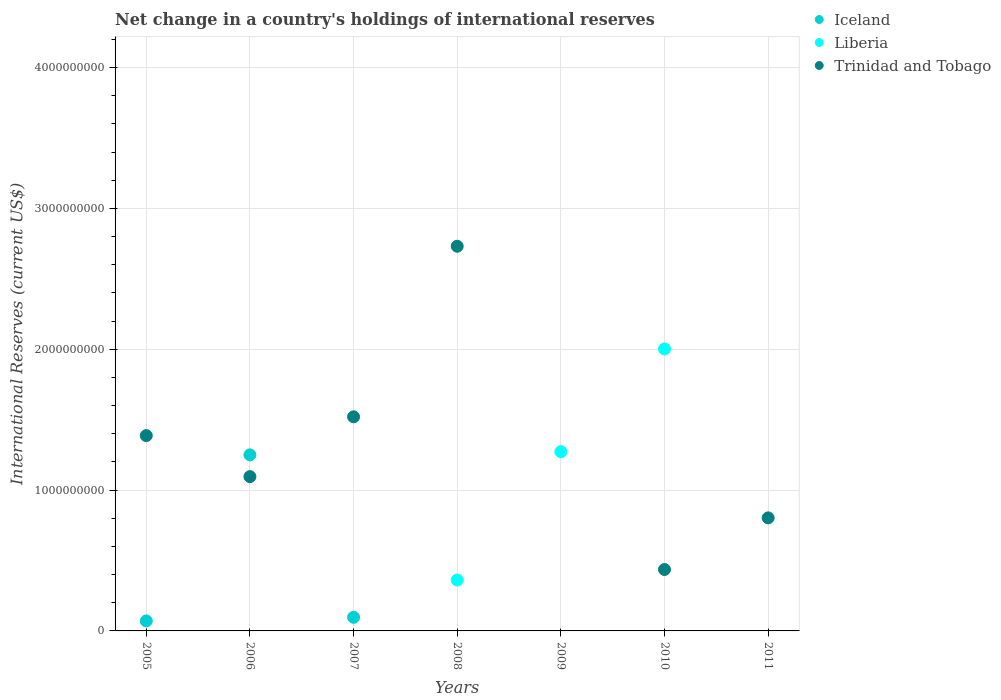How many different coloured dotlines are there?
Keep it short and to the point. 3. Is the number of dotlines equal to the number of legend labels?
Offer a terse response. No. What is the international reserves in Trinidad and Tobago in 2011?
Provide a succinct answer. 8.03e+08. Across all years, what is the maximum international reserves in Liberia?
Provide a short and direct response. 2.00e+09. Across all years, what is the minimum international reserves in Trinidad and Tobago?
Your answer should be very brief. 0. In which year was the international reserves in Iceland maximum?
Your response must be concise. 2006. What is the total international reserves in Trinidad and Tobago in the graph?
Keep it short and to the point. 7.97e+09. What is the difference between the international reserves in Iceland in 2006 and that in 2007?
Provide a succinct answer. 1.15e+09. What is the difference between the international reserves in Iceland in 2011 and the international reserves in Liberia in 2005?
Give a very brief answer. 0. What is the average international reserves in Liberia per year?
Keep it short and to the point. 5.20e+08. In the year 2008, what is the difference between the international reserves in Trinidad and Tobago and international reserves in Liberia?
Your response must be concise. 2.37e+09. What is the ratio of the international reserves in Liberia in 2009 to that in 2010?
Offer a terse response. 0.64. What is the difference between the highest and the second highest international reserves in Liberia?
Provide a short and direct response. 7.30e+08. What is the difference between the highest and the lowest international reserves in Trinidad and Tobago?
Provide a short and direct response. 2.73e+09. Is the sum of the international reserves in Trinidad and Tobago in 2008 and 2010 greater than the maximum international reserves in Iceland across all years?
Provide a short and direct response. Yes. Is the international reserves in Iceland strictly greater than the international reserves in Trinidad and Tobago over the years?
Offer a terse response. No. How many dotlines are there?
Offer a very short reply. 3. What is the difference between two consecutive major ticks on the Y-axis?
Give a very brief answer. 1.00e+09. Are the values on the major ticks of Y-axis written in scientific E-notation?
Keep it short and to the point. No. Does the graph contain any zero values?
Give a very brief answer. Yes. What is the title of the graph?
Provide a succinct answer. Net change in a country's holdings of international reserves. Does "Australia" appear as one of the legend labels in the graph?
Offer a terse response. No. What is the label or title of the X-axis?
Offer a very short reply. Years. What is the label or title of the Y-axis?
Your answer should be very brief. International Reserves (current US$). What is the International Reserves (current US$) of Iceland in 2005?
Provide a succinct answer. 7.10e+07. What is the International Reserves (current US$) in Trinidad and Tobago in 2005?
Your answer should be compact. 1.39e+09. What is the International Reserves (current US$) in Iceland in 2006?
Your answer should be compact. 1.25e+09. What is the International Reserves (current US$) of Liberia in 2006?
Your response must be concise. 0. What is the International Reserves (current US$) of Trinidad and Tobago in 2006?
Offer a very short reply. 1.10e+09. What is the International Reserves (current US$) in Iceland in 2007?
Ensure brevity in your answer.  9.67e+07. What is the International Reserves (current US$) in Trinidad and Tobago in 2007?
Keep it short and to the point. 1.52e+09. What is the International Reserves (current US$) in Liberia in 2008?
Your answer should be compact. 3.61e+08. What is the International Reserves (current US$) of Trinidad and Tobago in 2008?
Provide a succinct answer. 2.73e+09. What is the International Reserves (current US$) in Liberia in 2009?
Give a very brief answer. 1.27e+09. What is the International Reserves (current US$) in Trinidad and Tobago in 2009?
Offer a very short reply. 0. What is the International Reserves (current US$) of Liberia in 2010?
Provide a succinct answer. 2.00e+09. What is the International Reserves (current US$) in Trinidad and Tobago in 2010?
Your answer should be compact. 4.36e+08. What is the International Reserves (current US$) of Iceland in 2011?
Provide a succinct answer. 0. What is the International Reserves (current US$) of Liberia in 2011?
Provide a succinct answer. 0. What is the International Reserves (current US$) in Trinidad and Tobago in 2011?
Offer a very short reply. 8.03e+08. Across all years, what is the maximum International Reserves (current US$) in Iceland?
Your response must be concise. 1.25e+09. Across all years, what is the maximum International Reserves (current US$) in Liberia?
Make the answer very short. 2.00e+09. Across all years, what is the maximum International Reserves (current US$) in Trinidad and Tobago?
Offer a terse response. 2.73e+09. Across all years, what is the minimum International Reserves (current US$) in Trinidad and Tobago?
Give a very brief answer. 0. What is the total International Reserves (current US$) in Iceland in the graph?
Offer a terse response. 1.42e+09. What is the total International Reserves (current US$) of Liberia in the graph?
Give a very brief answer. 3.64e+09. What is the total International Reserves (current US$) of Trinidad and Tobago in the graph?
Provide a succinct answer. 7.97e+09. What is the difference between the International Reserves (current US$) of Iceland in 2005 and that in 2006?
Your answer should be very brief. -1.18e+09. What is the difference between the International Reserves (current US$) in Trinidad and Tobago in 2005 and that in 2006?
Provide a succinct answer. 2.91e+08. What is the difference between the International Reserves (current US$) in Iceland in 2005 and that in 2007?
Your response must be concise. -2.57e+07. What is the difference between the International Reserves (current US$) of Trinidad and Tobago in 2005 and that in 2007?
Make the answer very short. -1.33e+08. What is the difference between the International Reserves (current US$) of Trinidad and Tobago in 2005 and that in 2008?
Make the answer very short. -1.34e+09. What is the difference between the International Reserves (current US$) of Trinidad and Tobago in 2005 and that in 2010?
Your answer should be compact. 9.51e+08. What is the difference between the International Reserves (current US$) of Trinidad and Tobago in 2005 and that in 2011?
Your response must be concise. 5.84e+08. What is the difference between the International Reserves (current US$) of Iceland in 2006 and that in 2007?
Keep it short and to the point. 1.15e+09. What is the difference between the International Reserves (current US$) of Trinidad and Tobago in 2006 and that in 2007?
Keep it short and to the point. -4.25e+08. What is the difference between the International Reserves (current US$) in Trinidad and Tobago in 2006 and that in 2008?
Provide a succinct answer. -1.64e+09. What is the difference between the International Reserves (current US$) of Trinidad and Tobago in 2006 and that in 2010?
Your answer should be compact. 6.60e+08. What is the difference between the International Reserves (current US$) in Trinidad and Tobago in 2006 and that in 2011?
Make the answer very short. 2.93e+08. What is the difference between the International Reserves (current US$) in Trinidad and Tobago in 2007 and that in 2008?
Ensure brevity in your answer.  -1.21e+09. What is the difference between the International Reserves (current US$) in Trinidad and Tobago in 2007 and that in 2010?
Your answer should be compact. 1.08e+09. What is the difference between the International Reserves (current US$) of Trinidad and Tobago in 2007 and that in 2011?
Make the answer very short. 7.18e+08. What is the difference between the International Reserves (current US$) of Liberia in 2008 and that in 2009?
Offer a very short reply. -9.12e+08. What is the difference between the International Reserves (current US$) in Liberia in 2008 and that in 2010?
Ensure brevity in your answer.  -1.64e+09. What is the difference between the International Reserves (current US$) in Trinidad and Tobago in 2008 and that in 2010?
Provide a succinct answer. 2.30e+09. What is the difference between the International Reserves (current US$) of Trinidad and Tobago in 2008 and that in 2011?
Give a very brief answer. 1.93e+09. What is the difference between the International Reserves (current US$) of Liberia in 2009 and that in 2010?
Keep it short and to the point. -7.30e+08. What is the difference between the International Reserves (current US$) in Trinidad and Tobago in 2010 and that in 2011?
Your response must be concise. -3.67e+08. What is the difference between the International Reserves (current US$) of Iceland in 2005 and the International Reserves (current US$) of Trinidad and Tobago in 2006?
Your response must be concise. -1.02e+09. What is the difference between the International Reserves (current US$) of Iceland in 2005 and the International Reserves (current US$) of Trinidad and Tobago in 2007?
Give a very brief answer. -1.45e+09. What is the difference between the International Reserves (current US$) in Iceland in 2005 and the International Reserves (current US$) in Liberia in 2008?
Your answer should be very brief. -2.90e+08. What is the difference between the International Reserves (current US$) of Iceland in 2005 and the International Reserves (current US$) of Trinidad and Tobago in 2008?
Provide a succinct answer. -2.66e+09. What is the difference between the International Reserves (current US$) in Iceland in 2005 and the International Reserves (current US$) in Liberia in 2009?
Your answer should be compact. -1.20e+09. What is the difference between the International Reserves (current US$) in Iceland in 2005 and the International Reserves (current US$) in Liberia in 2010?
Keep it short and to the point. -1.93e+09. What is the difference between the International Reserves (current US$) in Iceland in 2005 and the International Reserves (current US$) in Trinidad and Tobago in 2010?
Give a very brief answer. -3.65e+08. What is the difference between the International Reserves (current US$) in Iceland in 2005 and the International Reserves (current US$) in Trinidad and Tobago in 2011?
Your response must be concise. -7.32e+08. What is the difference between the International Reserves (current US$) in Iceland in 2006 and the International Reserves (current US$) in Trinidad and Tobago in 2007?
Your answer should be very brief. -2.70e+08. What is the difference between the International Reserves (current US$) of Iceland in 2006 and the International Reserves (current US$) of Liberia in 2008?
Provide a short and direct response. 8.89e+08. What is the difference between the International Reserves (current US$) in Iceland in 2006 and the International Reserves (current US$) in Trinidad and Tobago in 2008?
Provide a succinct answer. -1.48e+09. What is the difference between the International Reserves (current US$) in Iceland in 2006 and the International Reserves (current US$) in Liberia in 2009?
Your answer should be compact. -2.28e+07. What is the difference between the International Reserves (current US$) in Iceland in 2006 and the International Reserves (current US$) in Liberia in 2010?
Provide a short and direct response. -7.52e+08. What is the difference between the International Reserves (current US$) in Iceland in 2006 and the International Reserves (current US$) in Trinidad and Tobago in 2010?
Offer a very short reply. 8.14e+08. What is the difference between the International Reserves (current US$) of Iceland in 2006 and the International Reserves (current US$) of Trinidad and Tobago in 2011?
Make the answer very short. 4.47e+08. What is the difference between the International Reserves (current US$) of Iceland in 2007 and the International Reserves (current US$) of Liberia in 2008?
Your answer should be very brief. -2.65e+08. What is the difference between the International Reserves (current US$) of Iceland in 2007 and the International Reserves (current US$) of Trinidad and Tobago in 2008?
Give a very brief answer. -2.63e+09. What is the difference between the International Reserves (current US$) of Iceland in 2007 and the International Reserves (current US$) of Liberia in 2009?
Your answer should be very brief. -1.18e+09. What is the difference between the International Reserves (current US$) in Iceland in 2007 and the International Reserves (current US$) in Liberia in 2010?
Ensure brevity in your answer.  -1.91e+09. What is the difference between the International Reserves (current US$) in Iceland in 2007 and the International Reserves (current US$) in Trinidad and Tobago in 2010?
Keep it short and to the point. -3.39e+08. What is the difference between the International Reserves (current US$) of Iceland in 2007 and the International Reserves (current US$) of Trinidad and Tobago in 2011?
Keep it short and to the point. -7.06e+08. What is the difference between the International Reserves (current US$) of Liberia in 2008 and the International Reserves (current US$) of Trinidad and Tobago in 2010?
Ensure brevity in your answer.  -7.47e+07. What is the difference between the International Reserves (current US$) in Liberia in 2008 and the International Reserves (current US$) in Trinidad and Tobago in 2011?
Ensure brevity in your answer.  -4.41e+08. What is the difference between the International Reserves (current US$) in Liberia in 2009 and the International Reserves (current US$) in Trinidad and Tobago in 2010?
Keep it short and to the point. 8.37e+08. What is the difference between the International Reserves (current US$) of Liberia in 2009 and the International Reserves (current US$) of Trinidad and Tobago in 2011?
Your answer should be very brief. 4.70e+08. What is the difference between the International Reserves (current US$) of Liberia in 2010 and the International Reserves (current US$) of Trinidad and Tobago in 2011?
Provide a succinct answer. 1.20e+09. What is the average International Reserves (current US$) of Iceland per year?
Your response must be concise. 2.03e+08. What is the average International Reserves (current US$) of Liberia per year?
Keep it short and to the point. 5.20e+08. What is the average International Reserves (current US$) in Trinidad and Tobago per year?
Your answer should be very brief. 1.14e+09. In the year 2005, what is the difference between the International Reserves (current US$) of Iceland and International Reserves (current US$) of Trinidad and Tobago?
Keep it short and to the point. -1.32e+09. In the year 2006, what is the difference between the International Reserves (current US$) in Iceland and International Reserves (current US$) in Trinidad and Tobago?
Make the answer very short. 1.54e+08. In the year 2007, what is the difference between the International Reserves (current US$) in Iceland and International Reserves (current US$) in Trinidad and Tobago?
Your answer should be compact. -1.42e+09. In the year 2008, what is the difference between the International Reserves (current US$) of Liberia and International Reserves (current US$) of Trinidad and Tobago?
Provide a short and direct response. -2.37e+09. In the year 2010, what is the difference between the International Reserves (current US$) of Liberia and International Reserves (current US$) of Trinidad and Tobago?
Keep it short and to the point. 1.57e+09. What is the ratio of the International Reserves (current US$) of Iceland in 2005 to that in 2006?
Offer a terse response. 0.06. What is the ratio of the International Reserves (current US$) of Trinidad and Tobago in 2005 to that in 2006?
Make the answer very short. 1.27. What is the ratio of the International Reserves (current US$) of Iceland in 2005 to that in 2007?
Make the answer very short. 0.73. What is the ratio of the International Reserves (current US$) of Trinidad and Tobago in 2005 to that in 2007?
Your answer should be compact. 0.91. What is the ratio of the International Reserves (current US$) in Trinidad and Tobago in 2005 to that in 2008?
Provide a short and direct response. 0.51. What is the ratio of the International Reserves (current US$) of Trinidad and Tobago in 2005 to that in 2010?
Your answer should be very brief. 3.18. What is the ratio of the International Reserves (current US$) in Trinidad and Tobago in 2005 to that in 2011?
Your answer should be very brief. 1.73. What is the ratio of the International Reserves (current US$) in Iceland in 2006 to that in 2007?
Provide a short and direct response. 12.93. What is the ratio of the International Reserves (current US$) of Trinidad and Tobago in 2006 to that in 2007?
Give a very brief answer. 0.72. What is the ratio of the International Reserves (current US$) of Trinidad and Tobago in 2006 to that in 2008?
Give a very brief answer. 0.4. What is the ratio of the International Reserves (current US$) of Trinidad and Tobago in 2006 to that in 2010?
Ensure brevity in your answer.  2.51. What is the ratio of the International Reserves (current US$) in Trinidad and Tobago in 2006 to that in 2011?
Provide a short and direct response. 1.36. What is the ratio of the International Reserves (current US$) in Trinidad and Tobago in 2007 to that in 2008?
Offer a very short reply. 0.56. What is the ratio of the International Reserves (current US$) of Trinidad and Tobago in 2007 to that in 2010?
Your answer should be very brief. 3.49. What is the ratio of the International Reserves (current US$) in Trinidad and Tobago in 2007 to that in 2011?
Offer a terse response. 1.89. What is the ratio of the International Reserves (current US$) in Liberia in 2008 to that in 2009?
Provide a short and direct response. 0.28. What is the ratio of the International Reserves (current US$) of Liberia in 2008 to that in 2010?
Provide a succinct answer. 0.18. What is the ratio of the International Reserves (current US$) in Trinidad and Tobago in 2008 to that in 2010?
Ensure brevity in your answer.  6.26. What is the ratio of the International Reserves (current US$) in Trinidad and Tobago in 2008 to that in 2011?
Give a very brief answer. 3.4. What is the ratio of the International Reserves (current US$) of Liberia in 2009 to that in 2010?
Offer a terse response. 0.64. What is the ratio of the International Reserves (current US$) in Trinidad and Tobago in 2010 to that in 2011?
Give a very brief answer. 0.54. What is the difference between the highest and the second highest International Reserves (current US$) of Iceland?
Make the answer very short. 1.15e+09. What is the difference between the highest and the second highest International Reserves (current US$) of Liberia?
Keep it short and to the point. 7.30e+08. What is the difference between the highest and the second highest International Reserves (current US$) in Trinidad and Tobago?
Your answer should be compact. 1.21e+09. What is the difference between the highest and the lowest International Reserves (current US$) of Iceland?
Keep it short and to the point. 1.25e+09. What is the difference between the highest and the lowest International Reserves (current US$) in Liberia?
Provide a short and direct response. 2.00e+09. What is the difference between the highest and the lowest International Reserves (current US$) in Trinidad and Tobago?
Keep it short and to the point. 2.73e+09. 